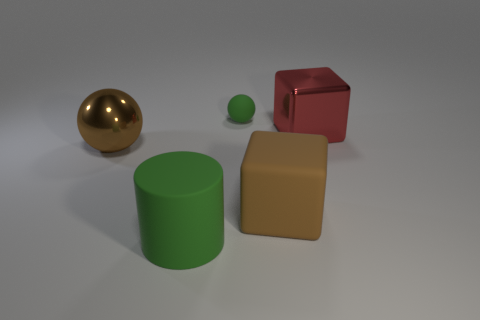Add 5 brown rubber blocks. How many objects exist? 10 Subtract all blocks. How many objects are left? 3 Subtract 0 gray cubes. How many objects are left? 5 Subtract all big purple metallic cylinders. Subtract all small rubber things. How many objects are left? 4 Add 4 red metal objects. How many red metal objects are left? 5 Add 3 green matte things. How many green matte things exist? 5 